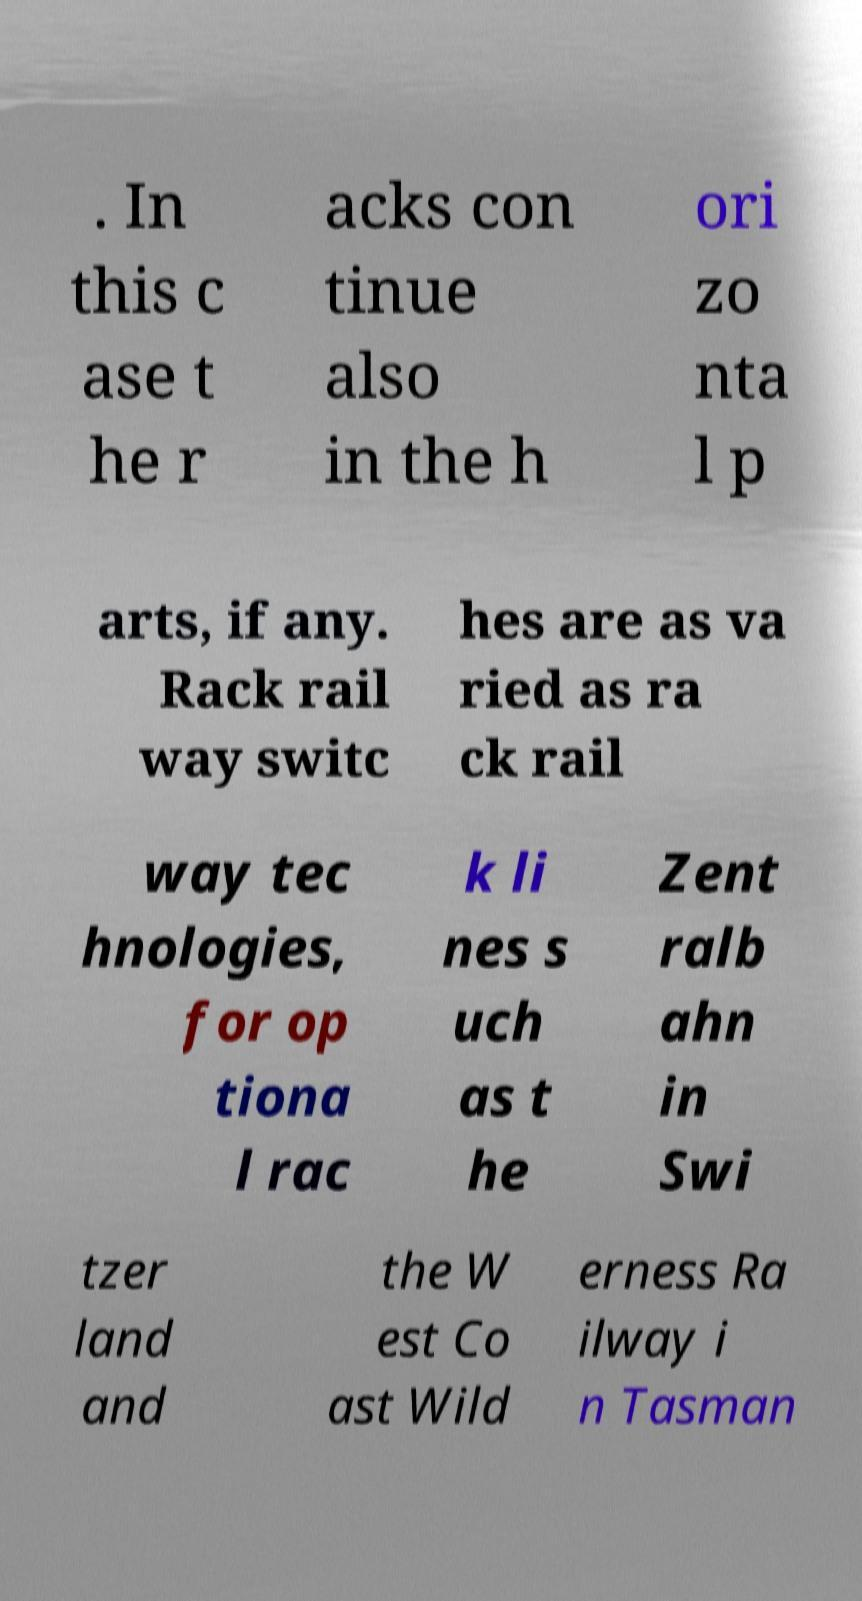For documentation purposes, I need the text within this image transcribed. Could you provide that? . In this c ase t he r acks con tinue also in the h ori zo nta l p arts, if any. Rack rail way switc hes are as va ried as ra ck rail way tec hnologies, for op tiona l rac k li nes s uch as t he Zent ralb ahn in Swi tzer land and the W est Co ast Wild erness Ra ilway i n Tasman 